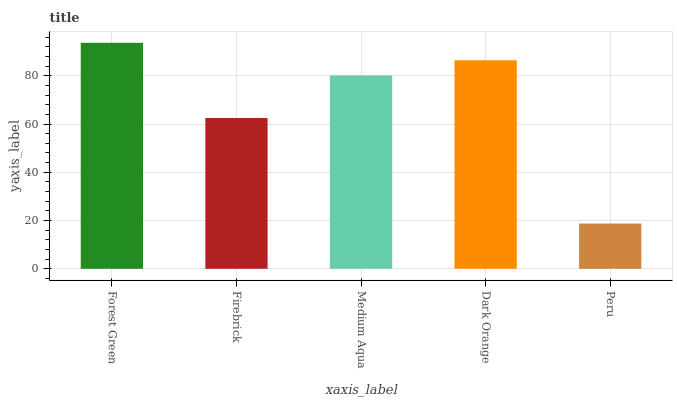Is Firebrick the minimum?
Answer yes or no. No. Is Firebrick the maximum?
Answer yes or no. No. Is Forest Green greater than Firebrick?
Answer yes or no. Yes. Is Firebrick less than Forest Green?
Answer yes or no. Yes. Is Firebrick greater than Forest Green?
Answer yes or no. No. Is Forest Green less than Firebrick?
Answer yes or no. No. Is Medium Aqua the high median?
Answer yes or no. Yes. Is Medium Aqua the low median?
Answer yes or no. Yes. Is Peru the high median?
Answer yes or no. No. Is Firebrick the low median?
Answer yes or no. No. 